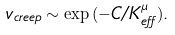<formula> <loc_0><loc_0><loc_500><loc_500>v _ { c r e e p } \sim \exp { ( - C / K _ { e f f } ^ { \mu } ) } .</formula> 